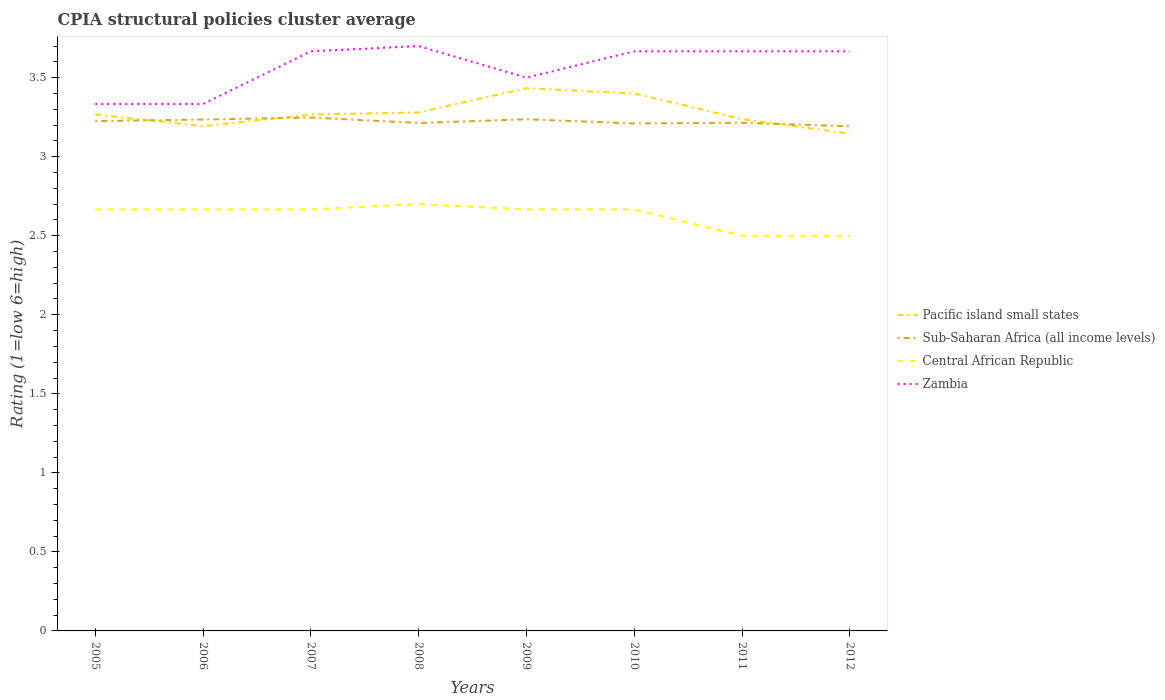How many different coloured lines are there?
Your answer should be very brief. 4. Does the line corresponding to Sub-Saharan Africa (all income levels) intersect with the line corresponding to Central African Republic?
Your answer should be compact. No. Across all years, what is the maximum CPIA rating in Pacific island small states?
Your answer should be compact. 3.15. In which year was the CPIA rating in Sub-Saharan Africa (all income levels) maximum?
Make the answer very short. 2012. What is the total CPIA rating in Pacific island small states in the graph?
Offer a terse response. -0.24. What is the difference between the highest and the second highest CPIA rating in Central African Republic?
Your answer should be compact. 0.2. Is the CPIA rating in Sub-Saharan Africa (all income levels) strictly greater than the CPIA rating in Zambia over the years?
Offer a very short reply. Yes. How many lines are there?
Offer a terse response. 4. How many years are there in the graph?
Ensure brevity in your answer.  8. What is the difference between two consecutive major ticks on the Y-axis?
Keep it short and to the point. 0.5. Does the graph contain grids?
Offer a very short reply. No. How many legend labels are there?
Your answer should be very brief. 4. What is the title of the graph?
Offer a terse response. CPIA structural policies cluster average. What is the label or title of the Y-axis?
Your answer should be very brief. Rating (1=low 6=high). What is the Rating (1=low 6=high) in Pacific island small states in 2005?
Ensure brevity in your answer.  3.27. What is the Rating (1=low 6=high) of Sub-Saharan Africa (all income levels) in 2005?
Offer a terse response. 3.23. What is the Rating (1=low 6=high) of Central African Republic in 2005?
Ensure brevity in your answer.  2.67. What is the Rating (1=low 6=high) in Zambia in 2005?
Offer a very short reply. 3.33. What is the Rating (1=low 6=high) in Pacific island small states in 2006?
Your answer should be very brief. 3.19. What is the Rating (1=low 6=high) of Sub-Saharan Africa (all income levels) in 2006?
Offer a terse response. 3.24. What is the Rating (1=low 6=high) in Central African Republic in 2006?
Your response must be concise. 2.67. What is the Rating (1=low 6=high) in Zambia in 2006?
Your response must be concise. 3.33. What is the Rating (1=low 6=high) in Pacific island small states in 2007?
Your answer should be very brief. 3.27. What is the Rating (1=low 6=high) of Sub-Saharan Africa (all income levels) in 2007?
Your answer should be compact. 3.25. What is the Rating (1=low 6=high) of Central African Republic in 2007?
Ensure brevity in your answer.  2.67. What is the Rating (1=low 6=high) of Zambia in 2007?
Your answer should be compact. 3.67. What is the Rating (1=low 6=high) of Pacific island small states in 2008?
Offer a terse response. 3.28. What is the Rating (1=low 6=high) of Sub-Saharan Africa (all income levels) in 2008?
Keep it short and to the point. 3.21. What is the Rating (1=low 6=high) in Central African Republic in 2008?
Offer a terse response. 2.7. What is the Rating (1=low 6=high) of Zambia in 2008?
Ensure brevity in your answer.  3.7. What is the Rating (1=low 6=high) in Pacific island small states in 2009?
Provide a short and direct response. 3.43. What is the Rating (1=low 6=high) in Sub-Saharan Africa (all income levels) in 2009?
Offer a very short reply. 3.24. What is the Rating (1=low 6=high) of Central African Republic in 2009?
Ensure brevity in your answer.  2.67. What is the Rating (1=low 6=high) in Zambia in 2009?
Provide a succinct answer. 3.5. What is the Rating (1=low 6=high) in Pacific island small states in 2010?
Ensure brevity in your answer.  3.4. What is the Rating (1=low 6=high) of Sub-Saharan Africa (all income levels) in 2010?
Ensure brevity in your answer.  3.21. What is the Rating (1=low 6=high) in Central African Republic in 2010?
Provide a succinct answer. 2.67. What is the Rating (1=low 6=high) in Zambia in 2010?
Make the answer very short. 3.67. What is the Rating (1=low 6=high) of Pacific island small states in 2011?
Your answer should be very brief. 3.24. What is the Rating (1=low 6=high) in Sub-Saharan Africa (all income levels) in 2011?
Your answer should be very brief. 3.21. What is the Rating (1=low 6=high) of Central African Republic in 2011?
Your answer should be compact. 2.5. What is the Rating (1=low 6=high) in Zambia in 2011?
Provide a short and direct response. 3.67. What is the Rating (1=low 6=high) in Pacific island small states in 2012?
Ensure brevity in your answer.  3.15. What is the Rating (1=low 6=high) of Sub-Saharan Africa (all income levels) in 2012?
Offer a terse response. 3.19. What is the Rating (1=low 6=high) of Zambia in 2012?
Offer a very short reply. 3.67. Across all years, what is the maximum Rating (1=low 6=high) in Pacific island small states?
Offer a terse response. 3.43. Across all years, what is the maximum Rating (1=low 6=high) in Sub-Saharan Africa (all income levels)?
Your answer should be compact. 3.25. Across all years, what is the minimum Rating (1=low 6=high) in Pacific island small states?
Your answer should be very brief. 3.15. Across all years, what is the minimum Rating (1=low 6=high) of Sub-Saharan Africa (all income levels)?
Make the answer very short. 3.19. Across all years, what is the minimum Rating (1=low 6=high) of Zambia?
Make the answer very short. 3.33. What is the total Rating (1=low 6=high) of Pacific island small states in the graph?
Ensure brevity in your answer.  26.22. What is the total Rating (1=low 6=high) of Sub-Saharan Africa (all income levels) in the graph?
Your answer should be compact. 25.78. What is the total Rating (1=low 6=high) of Central African Republic in the graph?
Your answer should be compact. 21.03. What is the total Rating (1=low 6=high) in Zambia in the graph?
Provide a succinct answer. 28.53. What is the difference between the Rating (1=low 6=high) of Pacific island small states in 2005 and that in 2006?
Offer a very short reply. 0.07. What is the difference between the Rating (1=low 6=high) in Sub-Saharan Africa (all income levels) in 2005 and that in 2006?
Ensure brevity in your answer.  -0.01. What is the difference between the Rating (1=low 6=high) of Zambia in 2005 and that in 2006?
Your answer should be very brief. 0. What is the difference between the Rating (1=low 6=high) of Pacific island small states in 2005 and that in 2007?
Offer a very short reply. 0. What is the difference between the Rating (1=low 6=high) of Sub-Saharan Africa (all income levels) in 2005 and that in 2007?
Keep it short and to the point. -0.02. What is the difference between the Rating (1=low 6=high) of Central African Republic in 2005 and that in 2007?
Provide a short and direct response. 0. What is the difference between the Rating (1=low 6=high) of Pacific island small states in 2005 and that in 2008?
Keep it short and to the point. -0.01. What is the difference between the Rating (1=low 6=high) of Sub-Saharan Africa (all income levels) in 2005 and that in 2008?
Provide a succinct answer. 0.01. What is the difference between the Rating (1=low 6=high) of Central African Republic in 2005 and that in 2008?
Your response must be concise. -0.03. What is the difference between the Rating (1=low 6=high) in Zambia in 2005 and that in 2008?
Provide a short and direct response. -0.37. What is the difference between the Rating (1=low 6=high) of Sub-Saharan Africa (all income levels) in 2005 and that in 2009?
Make the answer very short. -0.01. What is the difference between the Rating (1=low 6=high) of Central African Republic in 2005 and that in 2009?
Your response must be concise. 0. What is the difference between the Rating (1=low 6=high) of Pacific island small states in 2005 and that in 2010?
Make the answer very short. -0.13. What is the difference between the Rating (1=low 6=high) in Sub-Saharan Africa (all income levels) in 2005 and that in 2010?
Ensure brevity in your answer.  0.01. What is the difference between the Rating (1=low 6=high) of Zambia in 2005 and that in 2010?
Provide a short and direct response. -0.33. What is the difference between the Rating (1=low 6=high) of Pacific island small states in 2005 and that in 2011?
Your answer should be very brief. 0.03. What is the difference between the Rating (1=low 6=high) in Sub-Saharan Africa (all income levels) in 2005 and that in 2011?
Offer a terse response. 0.01. What is the difference between the Rating (1=low 6=high) of Pacific island small states in 2005 and that in 2012?
Provide a short and direct response. 0.12. What is the difference between the Rating (1=low 6=high) of Sub-Saharan Africa (all income levels) in 2005 and that in 2012?
Give a very brief answer. 0.03. What is the difference between the Rating (1=low 6=high) in Central African Republic in 2005 and that in 2012?
Make the answer very short. 0.17. What is the difference between the Rating (1=low 6=high) in Zambia in 2005 and that in 2012?
Provide a succinct answer. -0.33. What is the difference between the Rating (1=low 6=high) in Pacific island small states in 2006 and that in 2007?
Provide a succinct answer. -0.07. What is the difference between the Rating (1=low 6=high) in Sub-Saharan Africa (all income levels) in 2006 and that in 2007?
Offer a very short reply. -0.01. What is the difference between the Rating (1=low 6=high) in Central African Republic in 2006 and that in 2007?
Offer a terse response. 0. What is the difference between the Rating (1=low 6=high) in Zambia in 2006 and that in 2007?
Keep it short and to the point. -0.33. What is the difference between the Rating (1=low 6=high) of Pacific island small states in 2006 and that in 2008?
Your answer should be compact. -0.09. What is the difference between the Rating (1=low 6=high) in Sub-Saharan Africa (all income levels) in 2006 and that in 2008?
Your response must be concise. 0.02. What is the difference between the Rating (1=low 6=high) of Central African Republic in 2006 and that in 2008?
Offer a very short reply. -0.03. What is the difference between the Rating (1=low 6=high) in Zambia in 2006 and that in 2008?
Keep it short and to the point. -0.37. What is the difference between the Rating (1=low 6=high) of Pacific island small states in 2006 and that in 2009?
Your response must be concise. -0.24. What is the difference between the Rating (1=low 6=high) of Sub-Saharan Africa (all income levels) in 2006 and that in 2009?
Provide a succinct answer. -0. What is the difference between the Rating (1=low 6=high) in Central African Republic in 2006 and that in 2009?
Your response must be concise. 0. What is the difference between the Rating (1=low 6=high) in Pacific island small states in 2006 and that in 2010?
Keep it short and to the point. -0.21. What is the difference between the Rating (1=low 6=high) of Sub-Saharan Africa (all income levels) in 2006 and that in 2010?
Offer a terse response. 0.02. What is the difference between the Rating (1=low 6=high) in Zambia in 2006 and that in 2010?
Your response must be concise. -0.33. What is the difference between the Rating (1=low 6=high) of Pacific island small states in 2006 and that in 2011?
Keep it short and to the point. -0.04. What is the difference between the Rating (1=low 6=high) of Sub-Saharan Africa (all income levels) in 2006 and that in 2011?
Offer a terse response. 0.02. What is the difference between the Rating (1=low 6=high) in Pacific island small states in 2006 and that in 2012?
Your answer should be compact. 0.05. What is the difference between the Rating (1=low 6=high) of Sub-Saharan Africa (all income levels) in 2006 and that in 2012?
Make the answer very short. 0.04. What is the difference between the Rating (1=low 6=high) of Zambia in 2006 and that in 2012?
Your response must be concise. -0.33. What is the difference between the Rating (1=low 6=high) in Pacific island small states in 2007 and that in 2008?
Ensure brevity in your answer.  -0.01. What is the difference between the Rating (1=low 6=high) of Sub-Saharan Africa (all income levels) in 2007 and that in 2008?
Offer a very short reply. 0.03. What is the difference between the Rating (1=low 6=high) in Central African Republic in 2007 and that in 2008?
Keep it short and to the point. -0.03. What is the difference between the Rating (1=low 6=high) of Zambia in 2007 and that in 2008?
Offer a terse response. -0.03. What is the difference between the Rating (1=low 6=high) in Sub-Saharan Africa (all income levels) in 2007 and that in 2009?
Provide a succinct answer. 0.01. What is the difference between the Rating (1=low 6=high) in Zambia in 2007 and that in 2009?
Your answer should be compact. 0.17. What is the difference between the Rating (1=low 6=high) of Pacific island small states in 2007 and that in 2010?
Ensure brevity in your answer.  -0.13. What is the difference between the Rating (1=low 6=high) of Sub-Saharan Africa (all income levels) in 2007 and that in 2010?
Your answer should be very brief. 0.04. What is the difference between the Rating (1=low 6=high) in Central African Republic in 2007 and that in 2010?
Your response must be concise. 0. What is the difference between the Rating (1=low 6=high) in Pacific island small states in 2007 and that in 2011?
Make the answer very short. 0.03. What is the difference between the Rating (1=low 6=high) of Sub-Saharan Africa (all income levels) in 2007 and that in 2011?
Provide a short and direct response. 0.03. What is the difference between the Rating (1=low 6=high) in Central African Republic in 2007 and that in 2011?
Provide a short and direct response. 0.17. What is the difference between the Rating (1=low 6=high) of Pacific island small states in 2007 and that in 2012?
Provide a succinct answer. 0.12. What is the difference between the Rating (1=low 6=high) in Sub-Saharan Africa (all income levels) in 2007 and that in 2012?
Give a very brief answer. 0.06. What is the difference between the Rating (1=low 6=high) in Central African Republic in 2007 and that in 2012?
Give a very brief answer. 0.17. What is the difference between the Rating (1=low 6=high) of Zambia in 2007 and that in 2012?
Offer a very short reply. 0. What is the difference between the Rating (1=low 6=high) of Pacific island small states in 2008 and that in 2009?
Make the answer very short. -0.15. What is the difference between the Rating (1=low 6=high) in Sub-Saharan Africa (all income levels) in 2008 and that in 2009?
Provide a succinct answer. -0.02. What is the difference between the Rating (1=low 6=high) of Zambia in 2008 and that in 2009?
Ensure brevity in your answer.  0.2. What is the difference between the Rating (1=low 6=high) in Pacific island small states in 2008 and that in 2010?
Give a very brief answer. -0.12. What is the difference between the Rating (1=low 6=high) in Sub-Saharan Africa (all income levels) in 2008 and that in 2010?
Offer a very short reply. 0. What is the difference between the Rating (1=low 6=high) of Central African Republic in 2008 and that in 2010?
Provide a short and direct response. 0.03. What is the difference between the Rating (1=low 6=high) in Pacific island small states in 2008 and that in 2011?
Your answer should be very brief. 0.04. What is the difference between the Rating (1=low 6=high) in Sub-Saharan Africa (all income levels) in 2008 and that in 2011?
Keep it short and to the point. -0. What is the difference between the Rating (1=low 6=high) in Zambia in 2008 and that in 2011?
Your response must be concise. 0.03. What is the difference between the Rating (1=low 6=high) in Pacific island small states in 2008 and that in 2012?
Your response must be concise. 0.13. What is the difference between the Rating (1=low 6=high) of Sub-Saharan Africa (all income levels) in 2008 and that in 2012?
Give a very brief answer. 0.02. What is the difference between the Rating (1=low 6=high) in Central African Republic in 2008 and that in 2012?
Give a very brief answer. 0.2. What is the difference between the Rating (1=low 6=high) of Zambia in 2008 and that in 2012?
Offer a terse response. 0.03. What is the difference between the Rating (1=low 6=high) in Pacific island small states in 2009 and that in 2010?
Your answer should be very brief. 0.03. What is the difference between the Rating (1=low 6=high) of Sub-Saharan Africa (all income levels) in 2009 and that in 2010?
Your response must be concise. 0.03. What is the difference between the Rating (1=low 6=high) of Central African Republic in 2009 and that in 2010?
Offer a terse response. 0. What is the difference between the Rating (1=low 6=high) in Pacific island small states in 2009 and that in 2011?
Your answer should be compact. 0.2. What is the difference between the Rating (1=low 6=high) in Sub-Saharan Africa (all income levels) in 2009 and that in 2011?
Give a very brief answer. 0.02. What is the difference between the Rating (1=low 6=high) in Central African Republic in 2009 and that in 2011?
Provide a succinct answer. 0.17. What is the difference between the Rating (1=low 6=high) in Zambia in 2009 and that in 2011?
Your answer should be very brief. -0.17. What is the difference between the Rating (1=low 6=high) in Pacific island small states in 2009 and that in 2012?
Provide a short and direct response. 0.29. What is the difference between the Rating (1=low 6=high) of Sub-Saharan Africa (all income levels) in 2009 and that in 2012?
Your answer should be very brief. 0.04. What is the difference between the Rating (1=low 6=high) of Pacific island small states in 2010 and that in 2011?
Your answer should be very brief. 0.16. What is the difference between the Rating (1=low 6=high) in Sub-Saharan Africa (all income levels) in 2010 and that in 2011?
Provide a short and direct response. -0. What is the difference between the Rating (1=low 6=high) in Central African Republic in 2010 and that in 2011?
Your answer should be compact. 0.17. What is the difference between the Rating (1=low 6=high) in Pacific island small states in 2010 and that in 2012?
Your answer should be compact. 0.25. What is the difference between the Rating (1=low 6=high) of Sub-Saharan Africa (all income levels) in 2010 and that in 2012?
Keep it short and to the point. 0.02. What is the difference between the Rating (1=low 6=high) of Zambia in 2010 and that in 2012?
Give a very brief answer. 0. What is the difference between the Rating (1=low 6=high) in Pacific island small states in 2011 and that in 2012?
Give a very brief answer. 0.09. What is the difference between the Rating (1=low 6=high) of Sub-Saharan Africa (all income levels) in 2011 and that in 2012?
Offer a very short reply. 0.02. What is the difference between the Rating (1=low 6=high) of Pacific island small states in 2005 and the Rating (1=low 6=high) of Sub-Saharan Africa (all income levels) in 2006?
Your response must be concise. 0.03. What is the difference between the Rating (1=low 6=high) of Pacific island small states in 2005 and the Rating (1=low 6=high) of Zambia in 2006?
Provide a succinct answer. -0.07. What is the difference between the Rating (1=low 6=high) of Sub-Saharan Africa (all income levels) in 2005 and the Rating (1=low 6=high) of Central African Republic in 2006?
Offer a terse response. 0.56. What is the difference between the Rating (1=low 6=high) of Sub-Saharan Africa (all income levels) in 2005 and the Rating (1=low 6=high) of Zambia in 2006?
Make the answer very short. -0.11. What is the difference between the Rating (1=low 6=high) of Pacific island small states in 2005 and the Rating (1=low 6=high) of Sub-Saharan Africa (all income levels) in 2007?
Provide a succinct answer. 0.02. What is the difference between the Rating (1=low 6=high) of Sub-Saharan Africa (all income levels) in 2005 and the Rating (1=low 6=high) of Central African Republic in 2007?
Your response must be concise. 0.56. What is the difference between the Rating (1=low 6=high) in Sub-Saharan Africa (all income levels) in 2005 and the Rating (1=low 6=high) in Zambia in 2007?
Your answer should be very brief. -0.44. What is the difference between the Rating (1=low 6=high) of Pacific island small states in 2005 and the Rating (1=low 6=high) of Sub-Saharan Africa (all income levels) in 2008?
Your answer should be very brief. 0.05. What is the difference between the Rating (1=low 6=high) in Pacific island small states in 2005 and the Rating (1=low 6=high) in Central African Republic in 2008?
Your answer should be very brief. 0.57. What is the difference between the Rating (1=low 6=high) in Pacific island small states in 2005 and the Rating (1=low 6=high) in Zambia in 2008?
Offer a terse response. -0.43. What is the difference between the Rating (1=low 6=high) of Sub-Saharan Africa (all income levels) in 2005 and the Rating (1=low 6=high) of Central African Republic in 2008?
Give a very brief answer. 0.53. What is the difference between the Rating (1=low 6=high) in Sub-Saharan Africa (all income levels) in 2005 and the Rating (1=low 6=high) in Zambia in 2008?
Ensure brevity in your answer.  -0.47. What is the difference between the Rating (1=low 6=high) in Central African Republic in 2005 and the Rating (1=low 6=high) in Zambia in 2008?
Offer a terse response. -1.03. What is the difference between the Rating (1=low 6=high) in Pacific island small states in 2005 and the Rating (1=low 6=high) in Sub-Saharan Africa (all income levels) in 2009?
Give a very brief answer. 0.03. What is the difference between the Rating (1=low 6=high) of Pacific island small states in 2005 and the Rating (1=low 6=high) of Central African Republic in 2009?
Offer a terse response. 0.6. What is the difference between the Rating (1=low 6=high) in Pacific island small states in 2005 and the Rating (1=low 6=high) in Zambia in 2009?
Your answer should be compact. -0.23. What is the difference between the Rating (1=low 6=high) in Sub-Saharan Africa (all income levels) in 2005 and the Rating (1=low 6=high) in Central African Republic in 2009?
Make the answer very short. 0.56. What is the difference between the Rating (1=low 6=high) in Sub-Saharan Africa (all income levels) in 2005 and the Rating (1=low 6=high) in Zambia in 2009?
Keep it short and to the point. -0.27. What is the difference between the Rating (1=low 6=high) of Pacific island small states in 2005 and the Rating (1=low 6=high) of Sub-Saharan Africa (all income levels) in 2010?
Provide a short and direct response. 0.06. What is the difference between the Rating (1=low 6=high) of Sub-Saharan Africa (all income levels) in 2005 and the Rating (1=low 6=high) of Central African Republic in 2010?
Give a very brief answer. 0.56. What is the difference between the Rating (1=low 6=high) of Sub-Saharan Africa (all income levels) in 2005 and the Rating (1=low 6=high) of Zambia in 2010?
Ensure brevity in your answer.  -0.44. What is the difference between the Rating (1=low 6=high) in Central African Republic in 2005 and the Rating (1=low 6=high) in Zambia in 2010?
Provide a short and direct response. -1. What is the difference between the Rating (1=low 6=high) in Pacific island small states in 2005 and the Rating (1=low 6=high) in Sub-Saharan Africa (all income levels) in 2011?
Make the answer very short. 0.05. What is the difference between the Rating (1=low 6=high) of Pacific island small states in 2005 and the Rating (1=low 6=high) of Central African Republic in 2011?
Ensure brevity in your answer.  0.77. What is the difference between the Rating (1=low 6=high) in Pacific island small states in 2005 and the Rating (1=low 6=high) in Zambia in 2011?
Make the answer very short. -0.4. What is the difference between the Rating (1=low 6=high) of Sub-Saharan Africa (all income levels) in 2005 and the Rating (1=low 6=high) of Central African Republic in 2011?
Provide a succinct answer. 0.73. What is the difference between the Rating (1=low 6=high) of Sub-Saharan Africa (all income levels) in 2005 and the Rating (1=low 6=high) of Zambia in 2011?
Your answer should be compact. -0.44. What is the difference between the Rating (1=low 6=high) of Central African Republic in 2005 and the Rating (1=low 6=high) of Zambia in 2011?
Provide a short and direct response. -1. What is the difference between the Rating (1=low 6=high) of Pacific island small states in 2005 and the Rating (1=low 6=high) of Sub-Saharan Africa (all income levels) in 2012?
Give a very brief answer. 0.07. What is the difference between the Rating (1=low 6=high) of Pacific island small states in 2005 and the Rating (1=low 6=high) of Central African Republic in 2012?
Ensure brevity in your answer.  0.77. What is the difference between the Rating (1=low 6=high) in Sub-Saharan Africa (all income levels) in 2005 and the Rating (1=low 6=high) in Central African Republic in 2012?
Your answer should be very brief. 0.73. What is the difference between the Rating (1=low 6=high) in Sub-Saharan Africa (all income levels) in 2005 and the Rating (1=low 6=high) in Zambia in 2012?
Ensure brevity in your answer.  -0.44. What is the difference between the Rating (1=low 6=high) of Pacific island small states in 2006 and the Rating (1=low 6=high) of Sub-Saharan Africa (all income levels) in 2007?
Your response must be concise. -0.05. What is the difference between the Rating (1=low 6=high) in Pacific island small states in 2006 and the Rating (1=low 6=high) in Central African Republic in 2007?
Provide a succinct answer. 0.53. What is the difference between the Rating (1=low 6=high) in Pacific island small states in 2006 and the Rating (1=low 6=high) in Zambia in 2007?
Ensure brevity in your answer.  -0.47. What is the difference between the Rating (1=low 6=high) in Sub-Saharan Africa (all income levels) in 2006 and the Rating (1=low 6=high) in Central African Republic in 2007?
Keep it short and to the point. 0.57. What is the difference between the Rating (1=low 6=high) of Sub-Saharan Africa (all income levels) in 2006 and the Rating (1=low 6=high) of Zambia in 2007?
Offer a terse response. -0.43. What is the difference between the Rating (1=low 6=high) of Pacific island small states in 2006 and the Rating (1=low 6=high) of Sub-Saharan Africa (all income levels) in 2008?
Ensure brevity in your answer.  -0.02. What is the difference between the Rating (1=low 6=high) in Pacific island small states in 2006 and the Rating (1=low 6=high) in Central African Republic in 2008?
Your answer should be very brief. 0.49. What is the difference between the Rating (1=low 6=high) of Pacific island small states in 2006 and the Rating (1=low 6=high) of Zambia in 2008?
Offer a very short reply. -0.51. What is the difference between the Rating (1=low 6=high) of Sub-Saharan Africa (all income levels) in 2006 and the Rating (1=low 6=high) of Central African Republic in 2008?
Provide a succinct answer. 0.54. What is the difference between the Rating (1=low 6=high) of Sub-Saharan Africa (all income levels) in 2006 and the Rating (1=low 6=high) of Zambia in 2008?
Give a very brief answer. -0.46. What is the difference between the Rating (1=low 6=high) in Central African Republic in 2006 and the Rating (1=low 6=high) in Zambia in 2008?
Your answer should be compact. -1.03. What is the difference between the Rating (1=low 6=high) in Pacific island small states in 2006 and the Rating (1=low 6=high) in Sub-Saharan Africa (all income levels) in 2009?
Provide a short and direct response. -0.04. What is the difference between the Rating (1=low 6=high) of Pacific island small states in 2006 and the Rating (1=low 6=high) of Central African Republic in 2009?
Keep it short and to the point. 0.53. What is the difference between the Rating (1=low 6=high) of Pacific island small states in 2006 and the Rating (1=low 6=high) of Zambia in 2009?
Your response must be concise. -0.31. What is the difference between the Rating (1=low 6=high) in Sub-Saharan Africa (all income levels) in 2006 and the Rating (1=low 6=high) in Central African Republic in 2009?
Keep it short and to the point. 0.57. What is the difference between the Rating (1=low 6=high) of Sub-Saharan Africa (all income levels) in 2006 and the Rating (1=low 6=high) of Zambia in 2009?
Keep it short and to the point. -0.26. What is the difference between the Rating (1=low 6=high) of Pacific island small states in 2006 and the Rating (1=low 6=high) of Sub-Saharan Africa (all income levels) in 2010?
Give a very brief answer. -0.02. What is the difference between the Rating (1=low 6=high) in Pacific island small states in 2006 and the Rating (1=low 6=high) in Central African Republic in 2010?
Provide a succinct answer. 0.53. What is the difference between the Rating (1=low 6=high) of Pacific island small states in 2006 and the Rating (1=low 6=high) of Zambia in 2010?
Offer a terse response. -0.47. What is the difference between the Rating (1=low 6=high) of Sub-Saharan Africa (all income levels) in 2006 and the Rating (1=low 6=high) of Central African Republic in 2010?
Make the answer very short. 0.57. What is the difference between the Rating (1=low 6=high) of Sub-Saharan Africa (all income levels) in 2006 and the Rating (1=low 6=high) of Zambia in 2010?
Keep it short and to the point. -0.43. What is the difference between the Rating (1=low 6=high) in Pacific island small states in 2006 and the Rating (1=low 6=high) in Sub-Saharan Africa (all income levels) in 2011?
Keep it short and to the point. -0.02. What is the difference between the Rating (1=low 6=high) in Pacific island small states in 2006 and the Rating (1=low 6=high) in Central African Republic in 2011?
Make the answer very short. 0.69. What is the difference between the Rating (1=low 6=high) in Pacific island small states in 2006 and the Rating (1=low 6=high) in Zambia in 2011?
Give a very brief answer. -0.47. What is the difference between the Rating (1=low 6=high) of Sub-Saharan Africa (all income levels) in 2006 and the Rating (1=low 6=high) of Central African Republic in 2011?
Offer a terse response. 0.74. What is the difference between the Rating (1=low 6=high) in Sub-Saharan Africa (all income levels) in 2006 and the Rating (1=low 6=high) in Zambia in 2011?
Provide a short and direct response. -0.43. What is the difference between the Rating (1=low 6=high) in Pacific island small states in 2006 and the Rating (1=low 6=high) in Central African Republic in 2012?
Your answer should be very brief. 0.69. What is the difference between the Rating (1=low 6=high) of Pacific island small states in 2006 and the Rating (1=low 6=high) of Zambia in 2012?
Offer a terse response. -0.47. What is the difference between the Rating (1=low 6=high) of Sub-Saharan Africa (all income levels) in 2006 and the Rating (1=low 6=high) of Central African Republic in 2012?
Your answer should be compact. 0.74. What is the difference between the Rating (1=low 6=high) of Sub-Saharan Africa (all income levels) in 2006 and the Rating (1=low 6=high) of Zambia in 2012?
Your answer should be very brief. -0.43. What is the difference between the Rating (1=low 6=high) in Central African Republic in 2006 and the Rating (1=low 6=high) in Zambia in 2012?
Provide a succinct answer. -1. What is the difference between the Rating (1=low 6=high) in Pacific island small states in 2007 and the Rating (1=low 6=high) in Sub-Saharan Africa (all income levels) in 2008?
Ensure brevity in your answer.  0.05. What is the difference between the Rating (1=low 6=high) of Pacific island small states in 2007 and the Rating (1=low 6=high) of Central African Republic in 2008?
Give a very brief answer. 0.57. What is the difference between the Rating (1=low 6=high) in Pacific island small states in 2007 and the Rating (1=low 6=high) in Zambia in 2008?
Provide a succinct answer. -0.43. What is the difference between the Rating (1=low 6=high) in Sub-Saharan Africa (all income levels) in 2007 and the Rating (1=low 6=high) in Central African Republic in 2008?
Your answer should be very brief. 0.55. What is the difference between the Rating (1=low 6=high) of Sub-Saharan Africa (all income levels) in 2007 and the Rating (1=low 6=high) of Zambia in 2008?
Give a very brief answer. -0.45. What is the difference between the Rating (1=low 6=high) in Central African Republic in 2007 and the Rating (1=low 6=high) in Zambia in 2008?
Your response must be concise. -1.03. What is the difference between the Rating (1=low 6=high) of Pacific island small states in 2007 and the Rating (1=low 6=high) of Sub-Saharan Africa (all income levels) in 2009?
Keep it short and to the point. 0.03. What is the difference between the Rating (1=low 6=high) of Pacific island small states in 2007 and the Rating (1=low 6=high) of Central African Republic in 2009?
Ensure brevity in your answer.  0.6. What is the difference between the Rating (1=low 6=high) in Pacific island small states in 2007 and the Rating (1=low 6=high) in Zambia in 2009?
Provide a succinct answer. -0.23. What is the difference between the Rating (1=low 6=high) in Sub-Saharan Africa (all income levels) in 2007 and the Rating (1=low 6=high) in Central African Republic in 2009?
Your response must be concise. 0.58. What is the difference between the Rating (1=low 6=high) of Sub-Saharan Africa (all income levels) in 2007 and the Rating (1=low 6=high) of Zambia in 2009?
Make the answer very short. -0.25. What is the difference between the Rating (1=low 6=high) of Pacific island small states in 2007 and the Rating (1=low 6=high) of Sub-Saharan Africa (all income levels) in 2010?
Your response must be concise. 0.06. What is the difference between the Rating (1=low 6=high) in Pacific island small states in 2007 and the Rating (1=low 6=high) in Central African Republic in 2010?
Provide a short and direct response. 0.6. What is the difference between the Rating (1=low 6=high) of Sub-Saharan Africa (all income levels) in 2007 and the Rating (1=low 6=high) of Central African Republic in 2010?
Offer a very short reply. 0.58. What is the difference between the Rating (1=low 6=high) of Sub-Saharan Africa (all income levels) in 2007 and the Rating (1=low 6=high) of Zambia in 2010?
Ensure brevity in your answer.  -0.42. What is the difference between the Rating (1=low 6=high) in Pacific island small states in 2007 and the Rating (1=low 6=high) in Sub-Saharan Africa (all income levels) in 2011?
Your response must be concise. 0.05. What is the difference between the Rating (1=low 6=high) of Pacific island small states in 2007 and the Rating (1=low 6=high) of Central African Republic in 2011?
Keep it short and to the point. 0.77. What is the difference between the Rating (1=low 6=high) in Pacific island small states in 2007 and the Rating (1=low 6=high) in Zambia in 2011?
Your answer should be very brief. -0.4. What is the difference between the Rating (1=low 6=high) of Sub-Saharan Africa (all income levels) in 2007 and the Rating (1=low 6=high) of Central African Republic in 2011?
Keep it short and to the point. 0.75. What is the difference between the Rating (1=low 6=high) in Sub-Saharan Africa (all income levels) in 2007 and the Rating (1=low 6=high) in Zambia in 2011?
Provide a succinct answer. -0.42. What is the difference between the Rating (1=low 6=high) in Pacific island small states in 2007 and the Rating (1=low 6=high) in Sub-Saharan Africa (all income levels) in 2012?
Keep it short and to the point. 0.07. What is the difference between the Rating (1=low 6=high) in Pacific island small states in 2007 and the Rating (1=low 6=high) in Central African Republic in 2012?
Make the answer very short. 0.77. What is the difference between the Rating (1=low 6=high) in Pacific island small states in 2007 and the Rating (1=low 6=high) in Zambia in 2012?
Your answer should be very brief. -0.4. What is the difference between the Rating (1=low 6=high) in Sub-Saharan Africa (all income levels) in 2007 and the Rating (1=low 6=high) in Central African Republic in 2012?
Keep it short and to the point. 0.75. What is the difference between the Rating (1=low 6=high) in Sub-Saharan Africa (all income levels) in 2007 and the Rating (1=low 6=high) in Zambia in 2012?
Keep it short and to the point. -0.42. What is the difference between the Rating (1=low 6=high) in Central African Republic in 2007 and the Rating (1=low 6=high) in Zambia in 2012?
Your answer should be very brief. -1. What is the difference between the Rating (1=low 6=high) in Pacific island small states in 2008 and the Rating (1=low 6=high) in Sub-Saharan Africa (all income levels) in 2009?
Ensure brevity in your answer.  0.04. What is the difference between the Rating (1=low 6=high) of Pacific island small states in 2008 and the Rating (1=low 6=high) of Central African Republic in 2009?
Your answer should be very brief. 0.61. What is the difference between the Rating (1=low 6=high) in Pacific island small states in 2008 and the Rating (1=low 6=high) in Zambia in 2009?
Provide a succinct answer. -0.22. What is the difference between the Rating (1=low 6=high) of Sub-Saharan Africa (all income levels) in 2008 and the Rating (1=low 6=high) of Central African Republic in 2009?
Keep it short and to the point. 0.55. What is the difference between the Rating (1=low 6=high) in Sub-Saharan Africa (all income levels) in 2008 and the Rating (1=low 6=high) in Zambia in 2009?
Offer a terse response. -0.29. What is the difference between the Rating (1=low 6=high) of Central African Republic in 2008 and the Rating (1=low 6=high) of Zambia in 2009?
Provide a succinct answer. -0.8. What is the difference between the Rating (1=low 6=high) in Pacific island small states in 2008 and the Rating (1=low 6=high) in Sub-Saharan Africa (all income levels) in 2010?
Offer a terse response. 0.07. What is the difference between the Rating (1=low 6=high) in Pacific island small states in 2008 and the Rating (1=low 6=high) in Central African Republic in 2010?
Give a very brief answer. 0.61. What is the difference between the Rating (1=low 6=high) of Pacific island small states in 2008 and the Rating (1=low 6=high) of Zambia in 2010?
Ensure brevity in your answer.  -0.39. What is the difference between the Rating (1=low 6=high) of Sub-Saharan Africa (all income levels) in 2008 and the Rating (1=low 6=high) of Central African Republic in 2010?
Keep it short and to the point. 0.55. What is the difference between the Rating (1=low 6=high) in Sub-Saharan Africa (all income levels) in 2008 and the Rating (1=low 6=high) in Zambia in 2010?
Make the answer very short. -0.45. What is the difference between the Rating (1=low 6=high) in Central African Republic in 2008 and the Rating (1=low 6=high) in Zambia in 2010?
Offer a terse response. -0.97. What is the difference between the Rating (1=low 6=high) of Pacific island small states in 2008 and the Rating (1=low 6=high) of Sub-Saharan Africa (all income levels) in 2011?
Keep it short and to the point. 0.07. What is the difference between the Rating (1=low 6=high) in Pacific island small states in 2008 and the Rating (1=low 6=high) in Central African Republic in 2011?
Your answer should be compact. 0.78. What is the difference between the Rating (1=low 6=high) of Pacific island small states in 2008 and the Rating (1=low 6=high) of Zambia in 2011?
Provide a short and direct response. -0.39. What is the difference between the Rating (1=low 6=high) of Sub-Saharan Africa (all income levels) in 2008 and the Rating (1=low 6=high) of Central African Republic in 2011?
Offer a very short reply. 0.71. What is the difference between the Rating (1=low 6=high) of Sub-Saharan Africa (all income levels) in 2008 and the Rating (1=low 6=high) of Zambia in 2011?
Your answer should be very brief. -0.45. What is the difference between the Rating (1=low 6=high) in Central African Republic in 2008 and the Rating (1=low 6=high) in Zambia in 2011?
Ensure brevity in your answer.  -0.97. What is the difference between the Rating (1=low 6=high) of Pacific island small states in 2008 and the Rating (1=low 6=high) of Sub-Saharan Africa (all income levels) in 2012?
Provide a short and direct response. 0.09. What is the difference between the Rating (1=low 6=high) of Pacific island small states in 2008 and the Rating (1=low 6=high) of Central African Republic in 2012?
Provide a succinct answer. 0.78. What is the difference between the Rating (1=low 6=high) of Pacific island small states in 2008 and the Rating (1=low 6=high) of Zambia in 2012?
Your response must be concise. -0.39. What is the difference between the Rating (1=low 6=high) of Sub-Saharan Africa (all income levels) in 2008 and the Rating (1=low 6=high) of Central African Republic in 2012?
Offer a very short reply. 0.71. What is the difference between the Rating (1=low 6=high) in Sub-Saharan Africa (all income levels) in 2008 and the Rating (1=low 6=high) in Zambia in 2012?
Provide a short and direct response. -0.45. What is the difference between the Rating (1=low 6=high) in Central African Republic in 2008 and the Rating (1=low 6=high) in Zambia in 2012?
Your answer should be very brief. -0.97. What is the difference between the Rating (1=low 6=high) of Pacific island small states in 2009 and the Rating (1=low 6=high) of Sub-Saharan Africa (all income levels) in 2010?
Give a very brief answer. 0.22. What is the difference between the Rating (1=low 6=high) in Pacific island small states in 2009 and the Rating (1=low 6=high) in Central African Republic in 2010?
Your answer should be compact. 0.77. What is the difference between the Rating (1=low 6=high) in Pacific island small states in 2009 and the Rating (1=low 6=high) in Zambia in 2010?
Offer a very short reply. -0.23. What is the difference between the Rating (1=low 6=high) in Sub-Saharan Africa (all income levels) in 2009 and the Rating (1=low 6=high) in Central African Republic in 2010?
Your answer should be compact. 0.57. What is the difference between the Rating (1=low 6=high) in Sub-Saharan Africa (all income levels) in 2009 and the Rating (1=low 6=high) in Zambia in 2010?
Offer a terse response. -0.43. What is the difference between the Rating (1=low 6=high) in Pacific island small states in 2009 and the Rating (1=low 6=high) in Sub-Saharan Africa (all income levels) in 2011?
Make the answer very short. 0.22. What is the difference between the Rating (1=low 6=high) in Pacific island small states in 2009 and the Rating (1=low 6=high) in Central African Republic in 2011?
Your response must be concise. 0.93. What is the difference between the Rating (1=low 6=high) of Pacific island small states in 2009 and the Rating (1=low 6=high) of Zambia in 2011?
Your answer should be very brief. -0.23. What is the difference between the Rating (1=low 6=high) in Sub-Saharan Africa (all income levels) in 2009 and the Rating (1=low 6=high) in Central African Republic in 2011?
Provide a short and direct response. 0.74. What is the difference between the Rating (1=low 6=high) of Sub-Saharan Africa (all income levels) in 2009 and the Rating (1=low 6=high) of Zambia in 2011?
Keep it short and to the point. -0.43. What is the difference between the Rating (1=low 6=high) of Pacific island small states in 2009 and the Rating (1=low 6=high) of Sub-Saharan Africa (all income levels) in 2012?
Offer a terse response. 0.24. What is the difference between the Rating (1=low 6=high) of Pacific island small states in 2009 and the Rating (1=low 6=high) of Central African Republic in 2012?
Your response must be concise. 0.93. What is the difference between the Rating (1=low 6=high) of Pacific island small states in 2009 and the Rating (1=low 6=high) of Zambia in 2012?
Keep it short and to the point. -0.23. What is the difference between the Rating (1=low 6=high) of Sub-Saharan Africa (all income levels) in 2009 and the Rating (1=low 6=high) of Central African Republic in 2012?
Give a very brief answer. 0.74. What is the difference between the Rating (1=low 6=high) of Sub-Saharan Africa (all income levels) in 2009 and the Rating (1=low 6=high) of Zambia in 2012?
Give a very brief answer. -0.43. What is the difference between the Rating (1=low 6=high) of Central African Republic in 2009 and the Rating (1=low 6=high) of Zambia in 2012?
Offer a very short reply. -1. What is the difference between the Rating (1=low 6=high) of Pacific island small states in 2010 and the Rating (1=low 6=high) of Sub-Saharan Africa (all income levels) in 2011?
Make the answer very short. 0.19. What is the difference between the Rating (1=low 6=high) of Pacific island small states in 2010 and the Rating (1=low 6=high) of Zambia in 2011?
Your response must be concise. -0.27. What is the difference between the Rating (1=low 6=high) in Sub-Saharan Africa (all income levels) in 2010 and the Rating (1=low 6=high) in Central African Republic in 2011?
Provide a short and direct response. 0.71. What is the difference between the Rating (1=low 6=high) of Sub-Saharan Africa (all income levels) in 2010 and the Rating (1=low 6=high) of Zambia in 2011?
Offer a very short reply. -0.46. What is the difference between the Rating (1=low 6=high) in Central African Republic in 2010 and the Rating (1=low 6=high) in Zambia in 2011?
Offer a very short reply. -1. What is the difference between the Rating (1=low 6=high) of Pacific island small states in 2010 and the Rating (1=low 6=high) of Sub-Saharan Africa (all income levels) in 2012?
Provide a succinct answer. 0.21. What is the difference between the Rating (1=low 6=high) of Pacific island small states in 2010 and the Rating (1=low 6=high) of Zambia in 2012?
Provide a short and direct response. -0.27. What is the difference between the Rating (1=low 6=high) in Sub-Saharan Africa (all income levels) in 2010 and the Rating (1=low 6=high) in Central African Republic in 2012?
Ensure brevity in your answer.  0.71. What is the difference between the Rating (1=low 6=high) in Sub-Saharan Africa (all income levels) in 2010 and the Rating (1=low 6=high) in Zambia in 2012?
Your answer should be compact. -0.46. What is the difference between the Rating (1=low 6=high) of Central African Republic in 2010 and the Rating (1=low 6=high) of Zambia in 2012?
Give a very brief answer. -1. What is the difference between the Rating (1=low 6=high) in Pacific island small states in 2011 and the Rating (1=low 6=high) in Sub-Saharan Africa (all income levels) in 2012?
Give a very brief answer. 0.05. What is the difference between the Rating (1=low 6=high) of Pacific island small states in 2011 and the Rating (1=low 6=high) of Central African Republic in 2012?
Provide a succinct answer. 0.74. What is the difference between the Rating (1=low 6=high) in Pacific island small states in 2011 and the Rating (1=low 6=high) in Zambia in 2012?
Your answer should be very brief. -0.43. What is the difference between the Rating (1=low 6=high) in Sub-Saharan Africa (all income levels) in 2011 and the Rating (1=low 6=high) in Central African Republic in 2012?
Give a very brief answer. 0.71. What is the difference between the Rating (1=low 6=high) of Sub-Saharan Africa (all income levels) in 2011 and the Rating (1=low 6=high) of Zambia in 2012?
Offer a very short reply. -0.45. What is the difference between the Rating (1=low 6=high) of Central African Republic in 2011 and the Rating (1=low 6=high) of Zambia in 2012?
Offer a terse response. -1.17. What is the average Rating (1=low 6=high) of Pacific island small states per year?
Give a very brief answer. 3.28. What is the average Rating (1=low 6=high) of Sub-Saharan Africa (all income levels) per year?
Provide a short and direct response. 3.22. What is the average Rating (1=low 6=high) of Central African Republic per year?
Your answer should be compact. 2.63. What is the average Rating (1=low 6=high) of Zambia per year?
Your response must be concise. 3.57. In the year 2005, what is the difference between the Rating (1=low 6=high) in Pacific island small states and Rating (1=low 6=high) in Sub-Saharan Africa (all income levels)?
Your response must be concise. 0.04. In the year 2005, what is the difference between the Rating (1=low 6=high) in Pacific island small states and Rating (1=low 6=high) in Central African Republic?
Ensure brevity in your answer.  0.6. In the year 2005, what is the difference between the Rating (1=low 6=high) of Pacific island small states and Rating (1=low 6=high) of Zambia?
Your answer should be compact. -0.07. In the year 2005, what is the difference between the Rating (1=low 6=high) in Sub-Saharan Africa (all income levels) and Rating (1=low 6=high) in Central African Republic?
Make the answer very short. 0.56. In the year 2005, what is the difference between the Rating (1=low 6=high) in Sub-Saharan Africa (all income levels) and Rating (1=low 6=high) in Zambia?
Your answer should be compact. -0.11. In the year 2006, what is the difference between the Rating (1=low 6=high) in Pacific island small states and Rating (1=low 6=high) in Sub-Saharan Africa (all income levels)?
Make the answer very short. -0.04. In the year 2006, what is the difference between the Rating (1=low 6=high) in Pacific island small states and Rating (1=low 6=high) in Central African Republic?
Ensure brevity in your answer.  0.53. In the year 2006, what is the difference between the Rating (1=low 6=high) of Pacific island small states and Rating (1=low 6=high) of Zambia?
Provide a short and direct response. -0.14. In the year 2006, what is the difference between the Rating (1=low 6=high) in Sub-Saharan Africa (all income levels) and Rating (1=low 6=high) in Central African Republic?
Your response must be concise. 0.57. In the year 2006, what is the difference between the Rating (1=low 6=high) of Sub-Saharan Africa (all income levels) and Rating (1=low 6=high) of Zambia?
Provide a short and direct response. -0.1. In the year 2006, what is the difference between the Rating (1=low 6=high) in Central African Republic and Rating (1=low 6=high) in Zambia?
Your answer should be compact. -0.67. In the year 2007, what is the difference between the Rating (1=low 6=high) in Pacific island small states and Rating (1=low 6=high) in Sub-Saharan Africa (all income levels)?
Provide a succinct answer. 0.02. In the year 2007, what is the difference between the Rating (1=low 6=high) of Pacific island small states and Rating (1=low 6=high) of Central African Republic?
Make the answer very short. 0.6. In the year 2007, what is the difference between the Rating (1=low 6=high) in Sub-Saharan Africa (all income levels) and Rating (1=low 6=high) in Central African Republic?
Your answer should be compact. 0.58. In the year 2007, what is the difference between the Rating (1=low 6=high) of Sub-Saharan Africa (all income levels) and Rating (1=low 6=high) of Zambia?
Your answer should be compact. -0.42. In the year 2007, what is the difference between the Rating (1=low 6=high) of Central African Republic and Rating (1=low 6=high) of Zambia?
Ensure brevity in your answer.  -1. In the year 2008, what is the difference between the Rating (1=low 6=high) in Pacific island small states and Rating (1=low 6=high) in Sub-Saharan Africa (all income levels)?
Give a very brief answer. 0.07. In the year 2008, what is the difference between the Rating (1=low 6=high) of Pacific island small states and Rating (1=low 6=high) of Central African Republic?
Make the answer very short. 0.58. In the year 2008, what is the difference between the Rating (1=low 6=high) in Pacific island small states and Rating (1=low 6=high) in Zambia?
Ensure brevity in your answer.  -0.42. In the year 2008, what is the difference between the Rating (1=low 6=high) of Sub-Saharan Africa (all income levels) and Rating (1=low 6=high) of Central African Republic?
Your answer should be compact. 0.51. In the year 2008, what is the difference between the Rating (1=low 6=high) in Sub-Saharan Africa (all income levels) and Rating (1=low 6=high) in Zambia?
Give a very brief answer. -0.49. In the year 2009, what is the difference between the Rating (1=low 6=high) in Pacific island small states and Rating (1=low 6=high) in Sub-Saharan Africa (all income levels)?
Your response must be concise. 0.2. In the year 2009, what is the difference between the Rating (1=low 6=high) of Pacific island small states and Rating (1=low 6=high) of Central African Republic?
Your response must be concise. 0.77. In the year 2009, what is the difference between the Rating (1=low 6=high) in Pacific island small states and Rating (1=low 6=high) in Zambia?
Make the answer very short. -0.07. In the year 2009, what is the difference between the Rating (1=low 6=high) of Sub-Saharan Africa (all income levels) and Rating (1=low 6=high) of Central African Republic?
Provide a short and direct response. 0.57. In the year 2009, what is the difference between the Rating (1=low 6=high) in Sub-Saharan Africa (all income levels) and Rating (1=low 6=high) in Zambia?
Provide a succinct answer. -0.26. In the year 2009, what is the difference between the Rating (1=low 6=high) in Central African Republic and Rating (1=low 6=high) in Zambia?
Make the answer very short. -0.83. In the year 2010, what is the difference between the Rating (1=low 6=high) in Pacific island small states and Rating (1=low 6=high) in Sub-Saharan Africa (all income levels)?
Your answer should be very brief. 0.19. In the year 2010, what is the difference between the Rating (1=low 6=high) in Pacific island small states and Rating (1=low 6=high) in Central African Republic?
Your answer should be compact. 0.73. In the year 2010, what is the difference between the Rating (1=low 6=high) in Pacific island small states and Rating (1=low 6=high) in Zambia?
Provide a short and direct response. -0.27. In the year 2010, what is the difference between the Rating (1=low 6=high) of Sub-Saharan Africa (all income levels) and Rating (1=low 6=high) of Central African Republic?
Provide a short and direct response. 0.54. In the year 2010, what is the difference between the Rating (1=low 6=high) of Sub-Saharan Africa (all income levels) and Rating (1=low 6=high) of Zambia?
Make the answer very short. -0.46. In the year 2011, what is the difference between the Rating (1=low 6=high) in Pacific island small states and Rating (1=low 6=high) in Sub-Saharan Africa (all income levels)?
Give a very brief answer. 0.02. In the year 2011, what is the difference between the Rating (1=low 6=high) in Pacific island small states and Rating (1=low 6=high) in Central African Republic?
Provide a short and direct response. 0.74. In the year 2011, what is the difference between the Rating (1=low 6=high) in Pacific island small states and Rating (1=low 6=high) in Zambia?
Keep it short and to the point. -0.43. In the year 2011, what is the difference between the Rating (1=low 6=high) of Sub-Saharan Africa (all income levels) and Rating (1=low 6=high) of Central African Republic?
Offer a very short reply. 0.71. In the year 2011, what is the difference between the Rating (1=low 6=high) in Sub-Saharan Africa (all income levels) and Rating (1=low 6=high) in Zambia?
Ensure brevity in your answer.  -0.45. In the year 2011, what is the difference between the Rating (1=low 6=high) of Central African Republic and Rating (1=low 6=high) of Zambia?
Offer a very short reply. -1.17. In the year 2012, what is the difference between the Rating (1=low 6=high) of Pacific island small states and Rating (1=low 6=high) of Sub-Saharan Africa (all income levels)?
Your response must be concise. -0.05. In the year 2012, what is the difference between the Rating (1=low 6=high) in Pacific island small states and Rating (1=low 6=high) in Central African Republic?
Your answer should be very brief. 0.65. In the year 2012, what is the difference between the Rating (1=low 6=high) in Pacific island small states and Rating (1=low 6=high) in Zambia?
Provide a short and direct response. -0.52. In the year 2012, what is the difference between the Rating (1=low 6=high) in Sub-Saharan Africa (all income levels) and Rating (1=low 6=high) in Central African Republic?
Ensure brevity in your answer.  0.69. In the year 2012, what is the difference between the Rating (1=low 6=high) of Sub-Saharan Africa (all income levels) and Rating (1=low 6=high) of Zambia?
Provide a succinct answer. -0.47. In the year 2012, what is the difference between the Rating (1=low 6=high) in Central African Republic and Rating (1=low 6=high) in Zambia?
Make the answer very short. -1.17. What is the ratio of the Rating (1=low 6=high) in Pacific island small states in 2005 to that in 2006?
Make the answer very short. 1.02. What is the ratio of the Rating (1=low 6=high) of Sub-Saharan Africa (all income levels) in 2005 to that in 2006?
Provide a succinct answer. 1. What is the ratio of the Rating (1=low 6=high) of Central African Republic in 2005 to that in 2006?
Provide a succinct answer. 1. What is the ratio of the Rating (1=low 6=high) of Sub-Saharan Africa (all income levels) in 2005 to that in 2007?
Your answer should be very brief. 0.99. What is the ratio of the Rating (1=low 6=high) of Zambia in 2005 to that in 2007?
Offer a very short reply. 0.91. What is the ratio of the Rating (1=low 6=high) of Pacific island small states in 2005 to that in 2008?
Offer a terse response. 1. What is the ratio of the Rating (1=low 6=high) of Sub-Saharan Africa (all income levels) in 2005 to that in 2008?
Ensure brevity in your answer.  1. What is the ratio of the Rating (1=low 6=high) in Central African Republic in 2005 to that in 2008?
Offer a very short reply. 0.99. What is the ratio of the Rating (1=low 6=high) of Zambia in 2005 to that in 2008?
Ensure brevity in your answer.  0.9. What is the ratio of the Rating (1=low 6=high) of Pacific island small states in 2005 to that in 2009?
Offer a terse response. 0.95. What is the ratio of the Rating (1=low 6=high) of Central African Republic in 2005 to that in 2009?
Offer a terse response. 1. What is the ratio of the Rating (1=low 6=high) of Pacific island small states in 2005 to that in 2010?
Your response must be concise. 0.96. What is the ratio of the Rating (1=low 6=high) in Central African Republic in 2005 to that in 2010?
Your answer should be compact. 1. What is the ratio of the Rating (1=low 6=high) in Zambia in 2005 to that in 2010?
Offer a very short reply. 0.91. What is the ratio of the Rating (1=low 6=high) of Pacific island small states in 2005 to that in 2011?
Keep it short and to the point. 1.01. What is the ratio of the Rating (1=low 6=high) of Sub-Saharan Africa (all income levels) in 2005 to that in 2011?
Your answer should be compact. 1. What is the ratio of the Rating (1=low 6=high) of Central African Republic in 2005 to that in 2011?
Offer a terse response. 1.07. What is the ratio of the Rating (1=low 6=high) of Pacific island small states in 2005 to that in 2012?
Your answer should be very brief. 1.04. What is the ratio of the Rating (1=low 6=high) of Sub-Saharan Africa (all income levels) in 2005 to that in 2012?
Offer a very short reply. 1.01. What is the ratio of the Rating (1=low 6=high) in Central African Republic in 2005 to that in 2012?
Your response must be concise. 1.07. What is the ratio of the Rating (1=low 6=high) of Pacific island small states in 2006 to that in 2007?
Offer a terse response. 0.98. What is the ratio of the Rating (1=low 6=high) in Sub-Saharan Africa (all income levels) in 2006 to that in 2007?
Your answer should be very brief. 1. What is the ratio of the Rating (1=low 6=high) of Central African Republic in 2006 to that in 2007?
Your answer should be very brief. 1. What is the ratio of the Rating (1=low 6=high) of Zambia in 2006 to that in 2007?
Provide a short and direct response. 0.91. What is the ratio of the Rating (1=low 6=high) of Pacific island small states in 2006 to that in 2008?
Offer a very short reply. 0.97. What is the ratio of the Rating (1=low 6=high) in Sub-Saharan Africa (all income levels) in 2006 to that in 2008?
Provide a short and direct response. 1.01. What is the ratio of the Rating (1=low 6=high) of Zambia in 2006 to that in 2008?
Offer a terse response. 0.9. What is the ratio of the Rating (1=low 6=high) of Pacific island small states in 2006 to that in 2009?
Your response must be concise. 0.93. What is the ratio of the Rating (1=low 6=high) in Sub-Saharan Africa (all income levels) in 2006 to that in 2009?
Your response must be concise. 1. What is the ratio of the Rating (1=low 6=high) of Zambia in 2006 to that in 2009?
Your response must be concise. 0.95. What is the ratio of the Rating (1=low 6=high) in Pacific island small states in 2006 to that in 2010?
Offer a very short reply. 0.94. What is the ratio of the Rating (1=low 6=high) in Sub-Saharan Africa (all income levels) in 2006 to that in 2010?
Provide a succinct answer. 1.01. What is the ratio of the Rating (1=low 6=high) of Central African Republic in 2006 to that in 2010?
Your response must be concise. 1. What is the ratio of the Rating (1=low 6=high) in Pacific island small states in 2006 to that in 2011?
Your response must be concise. 0.99. What is the ratio of the Rating (1=low 6=high) of Central African Republic in 2006 to that in 2011?
Offer a terse response. 1.07. What is the ratio of the Rating (1=low 6=high) in Zambia in 2006 to that in 2011?
Keep it short and to the point. 0.91. What is the ratio of the Rating (1=low 6=high) of Pacific island small states in 2006 to that in 2012?
Give a very brief answer. 1.02. What is the ratio of the Rating (1=low 6=high) of Sub-Saharan Africa (all income levels) in 2006 to that in 2012?
Your answer should be compact. 1.01. What is the ratio of the Rating (1=low 6=high) of Central African Republic in 2006 to that in 2012?
Offer a terse response. 1.07. What is the ratio of the Rating (1=low 6=high) of Zambia in 2006 to that in 2012?
Your response must be concise. 0.91. What is the ratio of the Rating (1=low 6=high) in Pacific island small states in 2007 to that in 2008?
Provide a short and direct response. 1. What is the ratio of the Rating (1=low 6=high) in Sub-Saharan Africa (all income levels) in 2007 to that in 2008?
Provide a short and direct response. 1.01. What is the ratio of the Rating (1=low 6=high) in Central African Republic in 2007 to that in 2008?
Your response must be concise. 0.99. What is the ratio of the Rating (1=low 6=high) of Pacific island small states in 2007 to that in 2009?
Give a very brief answer. 0.95. What is the ratio of the Rating (1=low 6=high) in Zambia in 2007 to that in 2009?
Make the answer very short. 1.05. What is the ratio of the Rating (1=low 6=high) of Pacific island small states in 2007 to that in 2010?
Ensure brevity in your answer.  0.96. What is the ratio of the Rating (1=low 6=high) in Sub-Saharan Africa (all income levels) in 2007 to that in 2010?
Ensure brevity in your answer.  1.01. What is the ratio of the Rating (1=low 6=high) in Zambia in 2007 to that in 2010?
Your response must be concise. 1. What is the ratio of the Rating (1=low 6=high) of Pacific island small states in 2007 to that in 2011?
Ensure brevity in your answer.  1.01. What is the ratio of the Rating (1=low 6=high) of Sub-Saharan Africa (all income levels) in 2007 to that in 2011?
Provide a short and direct response. 1.01. What is the ratio of the Rating (1=low 6=high) of Central African Republic in 2007 to that in 2011?
Your answer should be very brief. 1.07. What is the ratio of the Rating (1=low 6=high) of Pacific island small states in 2007 to that in 2012?
Provide a short and direct response. 1.04. What is the ratio of the Rating (1=low 6=high) of Sub-Saharan Africa (all income levels) in 2007 to that in 2012?
Provide a short and direct response. 1.02. What is the ratio of the Rating (1=low 6=high) in Central African Republic in 2007 to that in 2012?
Your answer should be very brief. 1.07. What is the ratio of the Rating (1=low 6=high) of Pacific island small states in 2008 to that in 2009?
Provide a short and direct response. 0.96. What is the ratio of the Rating (1=low 6=high) of Sub-Saharan Africa (all income levels) in 2008 to that in 2009?
Offer a very short reply. 0.99. What is the ratio of the Rating (1=low 6=high) in Central African Republic in 2008 to that in 2009?
Give a very brief answer. 1.01. What is the ratio of the Rating (1=low 6=high) in Zambia in 2008 to that in 2009?
Provide a succinct answer. 1.06. What is the ratio of the Rating (1=low 6=high) of Pacific island small states in 2008 to that in 2010?
Your answer should be very brief. 0.96. What is the ratio of the Rating (1=low 6=high) of Central African Republic in 2008 to that in 2010?
Keep it short and to the point. 1.01. What is the ratio of the Rating (1=low 6=high) in Zambia in 2008 to that in 2010?
Your answer should be compact. 1.01. What is the ratio of the Rating (1=low 6=high) of Pacific island small states in 2008 to that in 2011?
Offer a terse response. 1.01. What is the ratio of the Rating (1=low 6=high) in Central African Republic in 2008 to that in 2011?
Your answer should be compact. 1.08. What is the ratio of the Rating (1=low 6=high) of Zambia in 2008 to that in 2011?
Offer a very short reply. 1.01. What is the ratio of the Rating (1=low 6=high) in Pacific island small states in 2008 to that in 2012?
Your answer should be very brief. 1.04. What is the ratio of the Rating (1=low 6=high) in Sub-Saharan Africa (all income levels) in 2008 to that in 2012?
Provide a short and direct response. 1.01. What is the ratio of the Rating (1=low 6=high) of Central African Republic in 2008 to that in 2012?
Your response must be concise. 1.08. What is the ratio of the Rating (1=low 6=high) of Zambia in 2008 to that in 2012?
Your response must be concise. 1.01. What is the ratio of the Rating (1=low 6=high) in Pacific island small states in 2009 to that in 2010?
Your answer should be compact. 1.01. What is the ratio of the Rating (1=low 6=high) of Sub-Saharan Africa (all income levels) in 2009 to that in 2010?
Offer a very short reply. 1.01. What is the ratio of the Rating (1=low 6=high) of Central African Republic in 2009 to that in 2010?
Give a very brief answer. 1. What is the ratio of the Rating (1=low 6=high) of Zambia in 2009 to that in 2010?
Provide a short and direct response. 0.95. What is the ratio of the Rating (1=low 6=high) of Pacific island small states in 2009 to that in 2011?
Provide a succinct answer. 1.06. What is the ratio of the Rating (1=low 6=high) in Sub-Saharan Africa (all income levels) in 2009 to that in 2011?
Ensure brevity in your answer.  1.01. What is the ratio of the Rating (1=low 6=high) of Central African Republic in 2009 to that in 2011?
Offer a terse response. 1.07. What is the ratio of the Rating (1=low 6=high) of Zambia in 2009 to that in 2011?
Your response must be concise. 0.95. What is the ratio of the Rating (1=low 6=high) of Pacific island small states in 2009 to that in 2012?
Your response must be concise. 1.09. What is the ratio of the Rating (1=low 6=high) in Central African Republic in 2009 to that in 2012?
Keep it short and to the point. 1.07. What is the ratio of the Rating (1=low 6=high) of Zambia in 2009 to that in 2012?
Your answer should be compact. 0.95. What is the ratio of the Rating (1=low 6=high) of Sub-Saharan Africa (all income levels) in 2010 to that in 2011?
Your answer should be very brief. 1. What is the ratio of the Rating (1=low 6=high) in Central African Republic in 2010 to that in 2011?
Offer a very short reply. 1.07. What is the ratio of the Rating (1=low 6=high) of Pacific island small states in 2010 to that in 2012?
Give a very brief answer. 1.08. What is the ratio of the Rating (1=low 6=high) of Central African Republic in 2010 to that in 2012?
Give a very brief answer. 1.07. What is the ratio of the Rating (1=low 6=high) of Pacific island small states in 2011 to that in 2012?
Your response must be concise. 1.03. What is the ratio of the Rating (1=low 6=high) of Sub-Saharan Africa (all income levels) in 2011 to that in 2012?
Offer a very short reply. 1.01. What is the ratio of the Rating (1=low 6=high) in Central African Republic in 2011 to that in 2012?
Provide a succinct answer. 1. What is the difference between the highest and the second highest Rating (1=low 6=high) of Pacific island small states?
Give a very brief answer. 0.03. What is the difference between the highest and the second highest Rating (1=low 6=high) in Sub-Saharan Africa (all income levels)?
Your response must be concise. 0.01. What is the difference between the highest and the second highest Rating (1=low 6=high) of Central African Republic?
Offer a very short reply. 0.03. What is the difference between the highest and the lowest Rating (1=low 6=high) of Pacific island small states?
Give a very brief answer. 0.29. What is the difference between the highest and the lowest Rating (1=low 6=high) of Sub-Saharan Africa (all income levels)?
Offer a terse response. 0.06. What is the difference between the highest and the lowest Rating (1=low 6=high) of Central African Republic?
Provide a succinct answer. 0.2. What is the difference between the highest and the lowest Rating (1=low 6=high) of Zambia?
Keep it short and to the point. 0.37. 